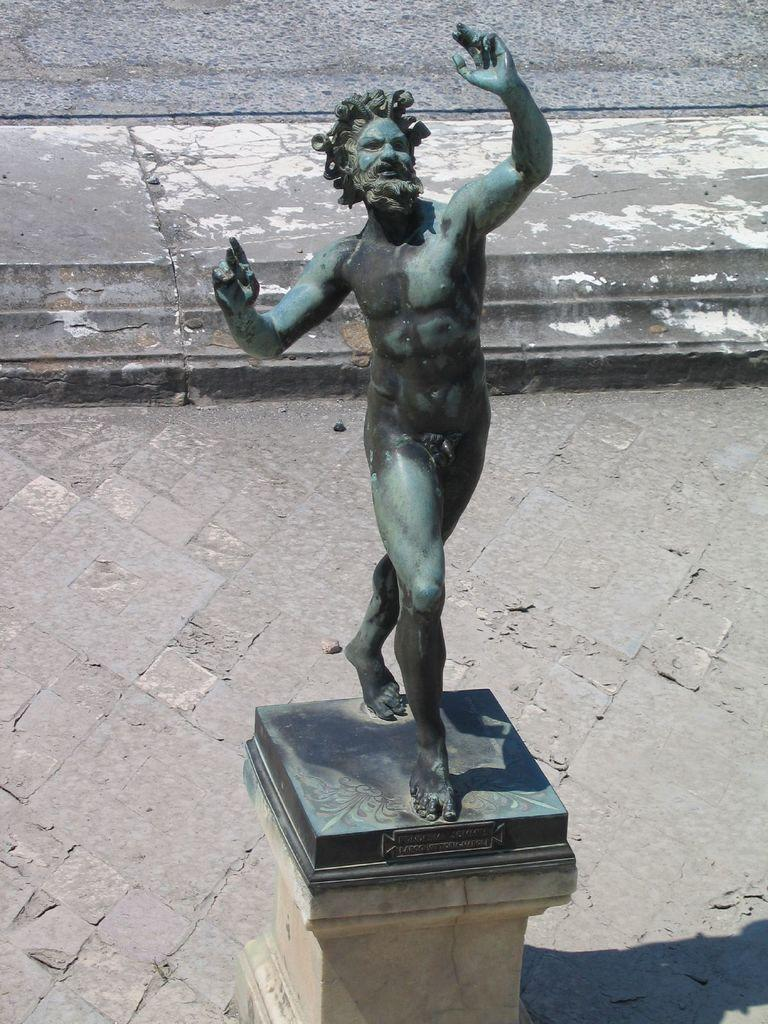What is the main subject in the center of the image? There is a statue in the center of the image. What else can be seen near the statue? There is text on a stand near the statue. What can be seen on the backside of the image? The ground is visible on the backside of the image. How does the zebra increase its power in the image? There is no zebra present in the image, so it cannot increase its power. 